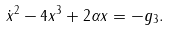Convert formula to latex. <formula><loc_0><loc_0><loc_500><loc_500>\dot { x } ^ { 2 } - 4 x ^ { 3 } + 2 \alpha x = - g _ { 3 } .</formula> 